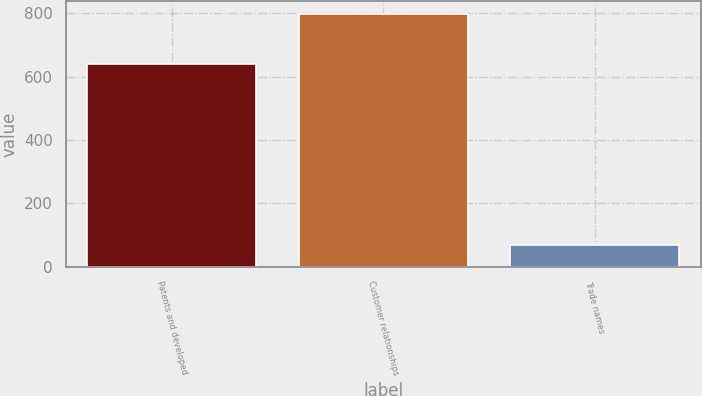Convert chart to OTSL. <chart><loc_0><loc_0><loc_500><loc_500><bar_chart><fcel>Patents and developed<fcel>Customer relationships<fcel>Trade names<nl><fcel>639<fcel>798<fcel>68<nl></chart> 